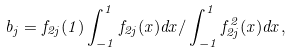<formula> <loc_0><loc_0><loc_500><loc_500>b _ { j } = f _ { 2 j } ( 1 ) \int ^ { 1 } _ { - 1 } f _ { 2 j } ( x ) d x / \int ^ { 1 } _ { - 1 } f ^ { 2 } _ { 2 j } ( x ) d x ,</formula> 